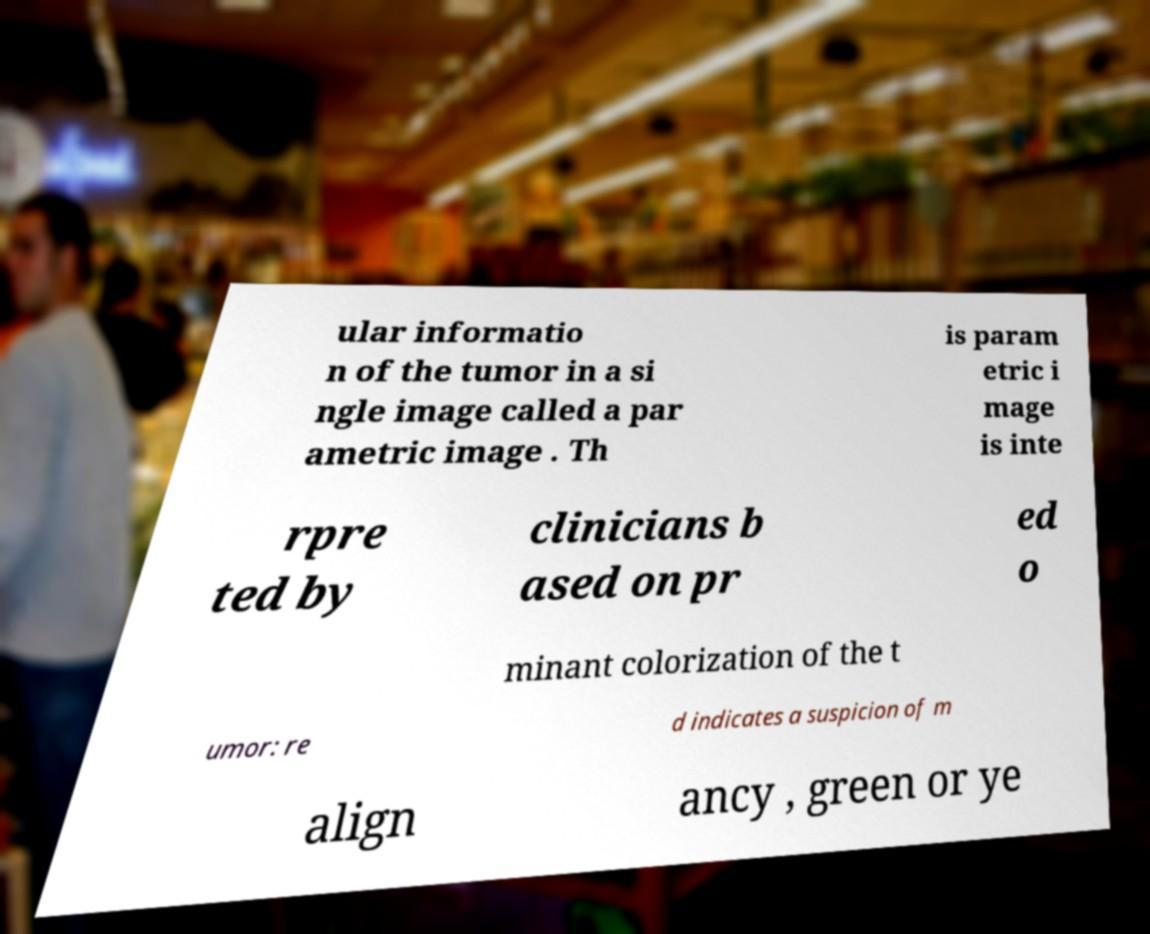For documentation purposes, I need the text within this image transcribed. Could you provide that? ular informatio n of the tumor in a si ngle image called a par ametric image . Th is param etric i mage is inte rpre ted by clinicians b ased on pr ed o minant colorization of the t umor: re d indicates a suspicion of m align ancy , green or ye 